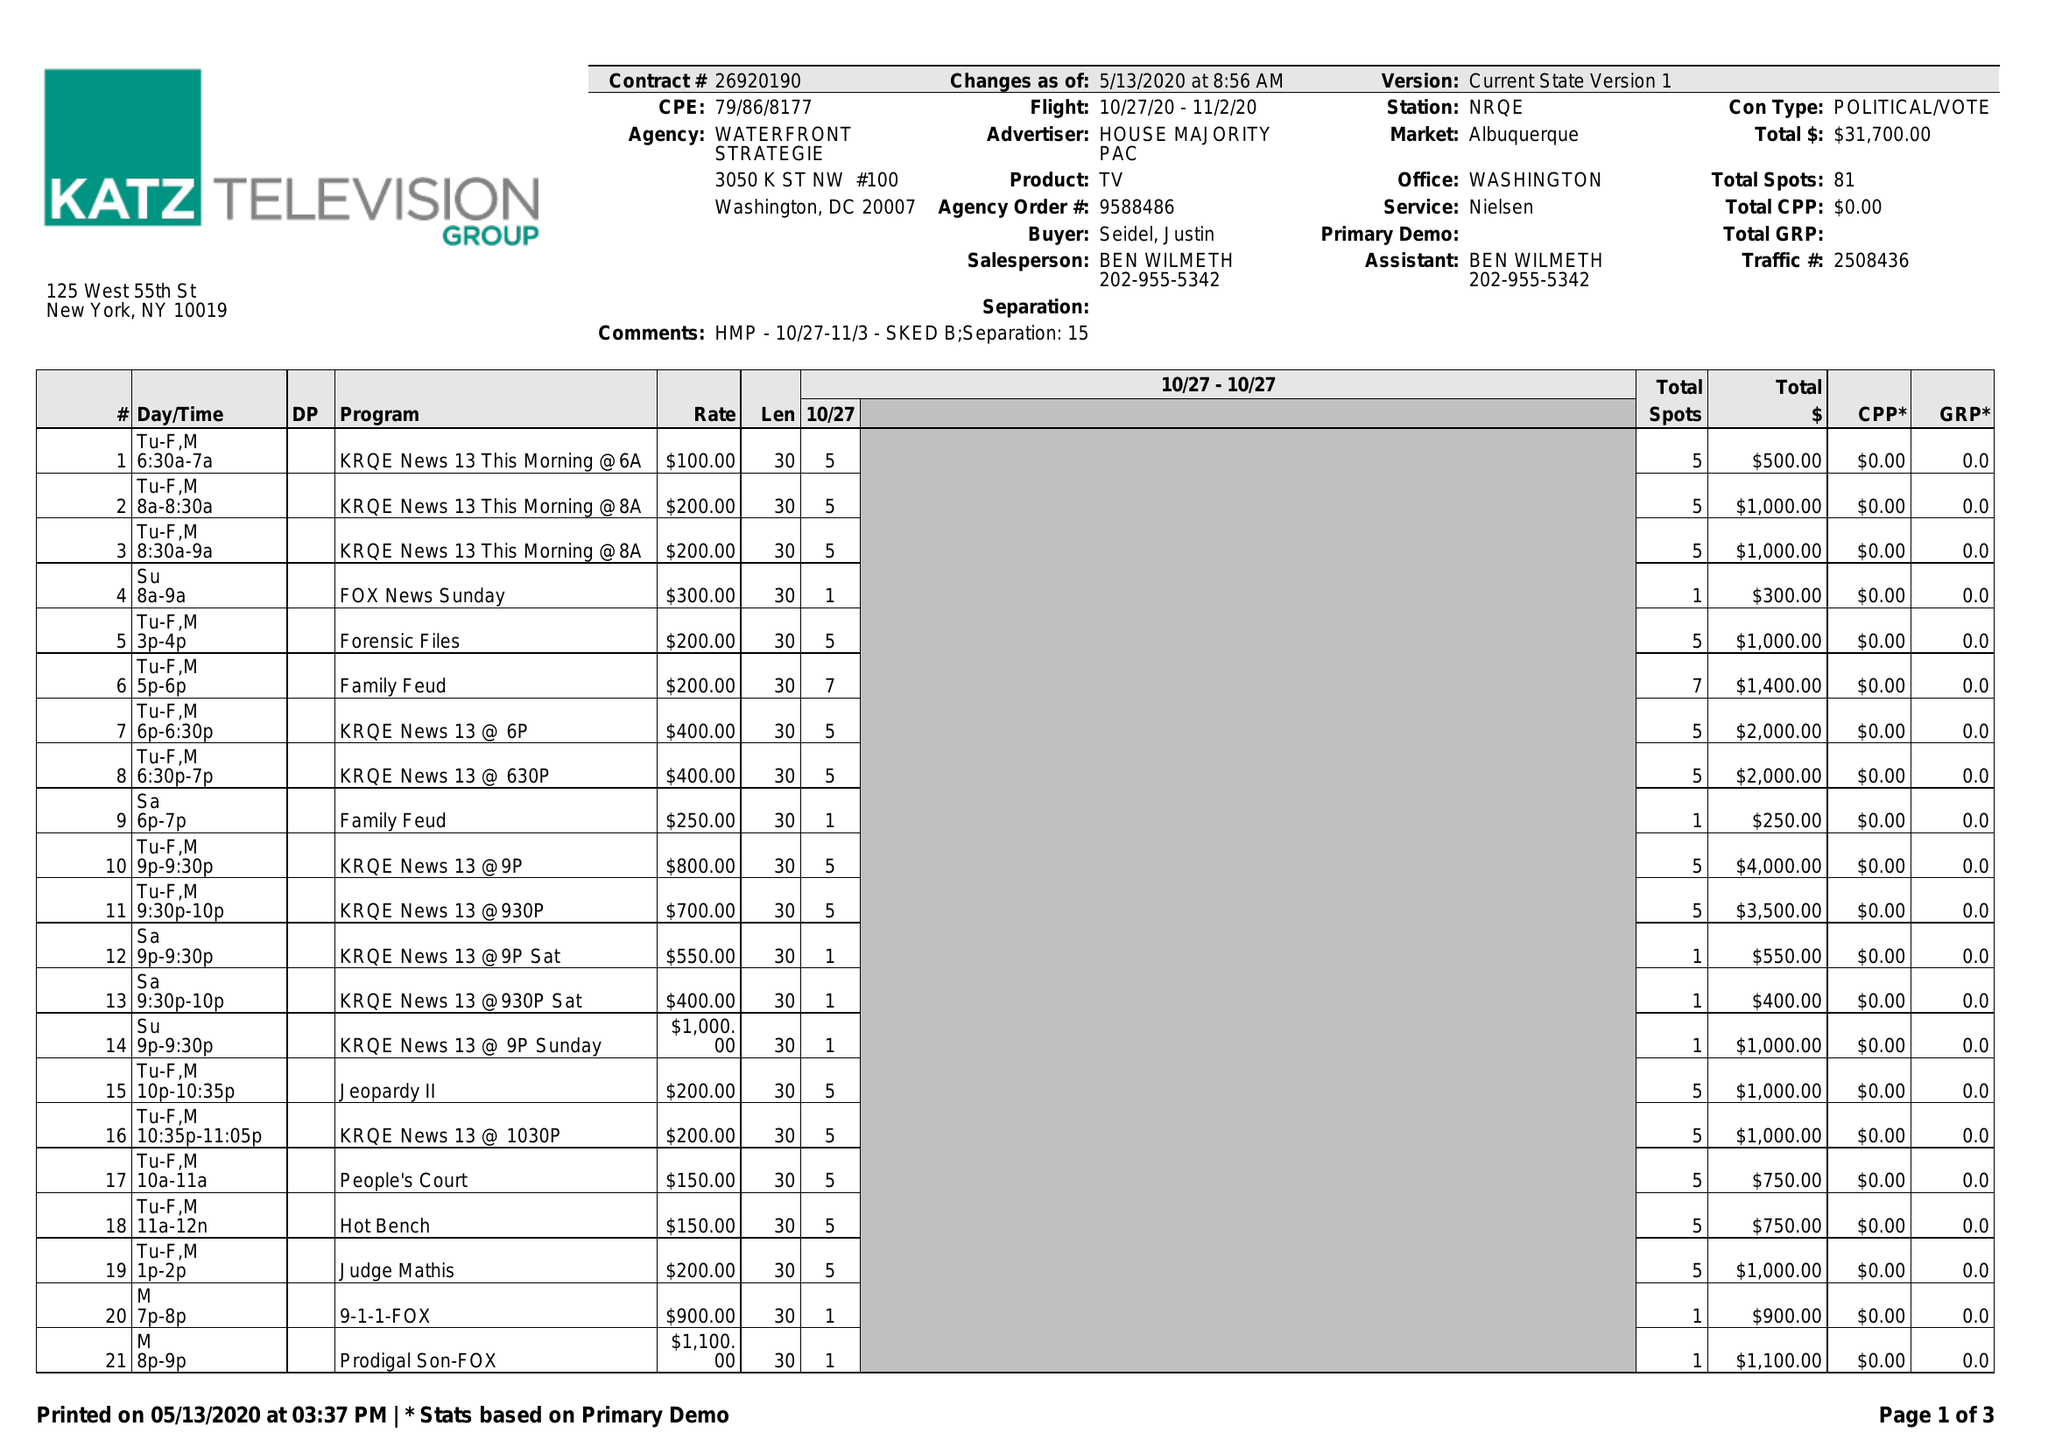What is the value for the gross_amount?
Answer the question using a single word or phrase. 31700.00 